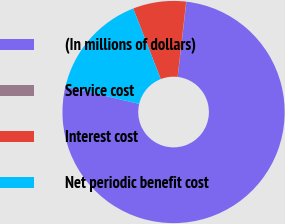Convert chart. <chart><loc_0><loc_0><loc_500><loc_500><pie_chart><fcel>(In millions of dollars)<fcel>Service cost<fcel>Interest cost<fcel>Net periodic benefit cost<nl><fcel>76.84%<fcel>0.04%<fcel>7.72%<fcel>15.4%<nl></chart> 